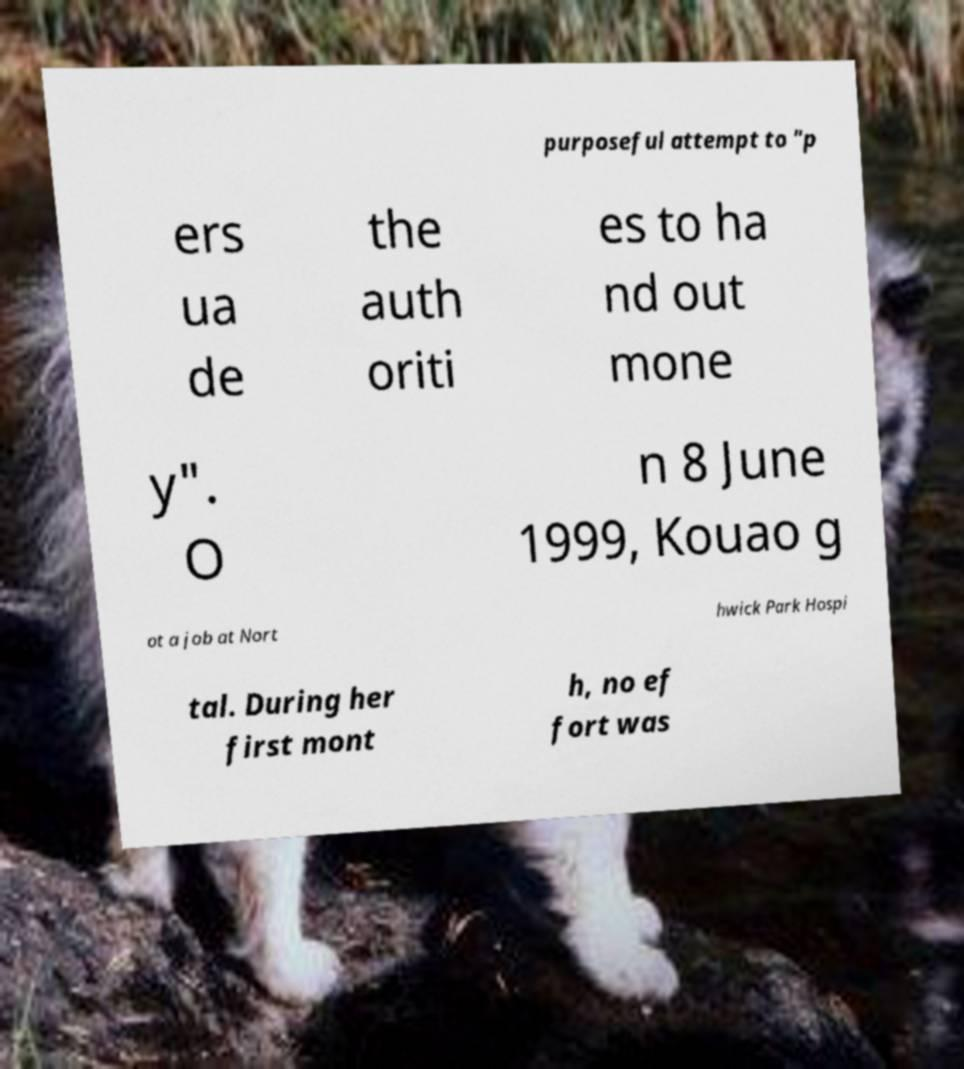There's text embedded in this image that I need extracted. Can you transcribe it verbatim? purposeful attempt to "p ers ua de the auth oriti es to ha nd out mone y". O n 8 June 1999, Kouao g ot a job at Nort hwick Park Hospi tal. During her first mont h, no ef fort was 